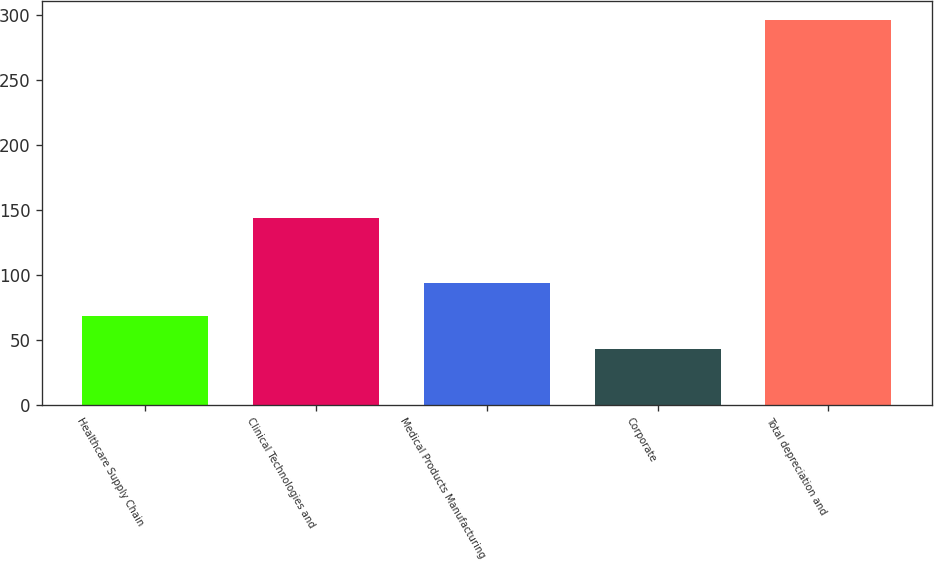Convert chart to OTSL. <chart><loc_0><loc_0><loc_500><loc_500><bar_chart><fcel>Healthcare Supply Chain<fcel>Clinical Technologies and<fcel>Medical Products Manufacturing<fcel>Corporate<fcel>Total depreciation and<nl><fcel>67.9<fcel>143.8<fcel>93.2<fcel>42.6<fcel>295.6<nl></chart> 